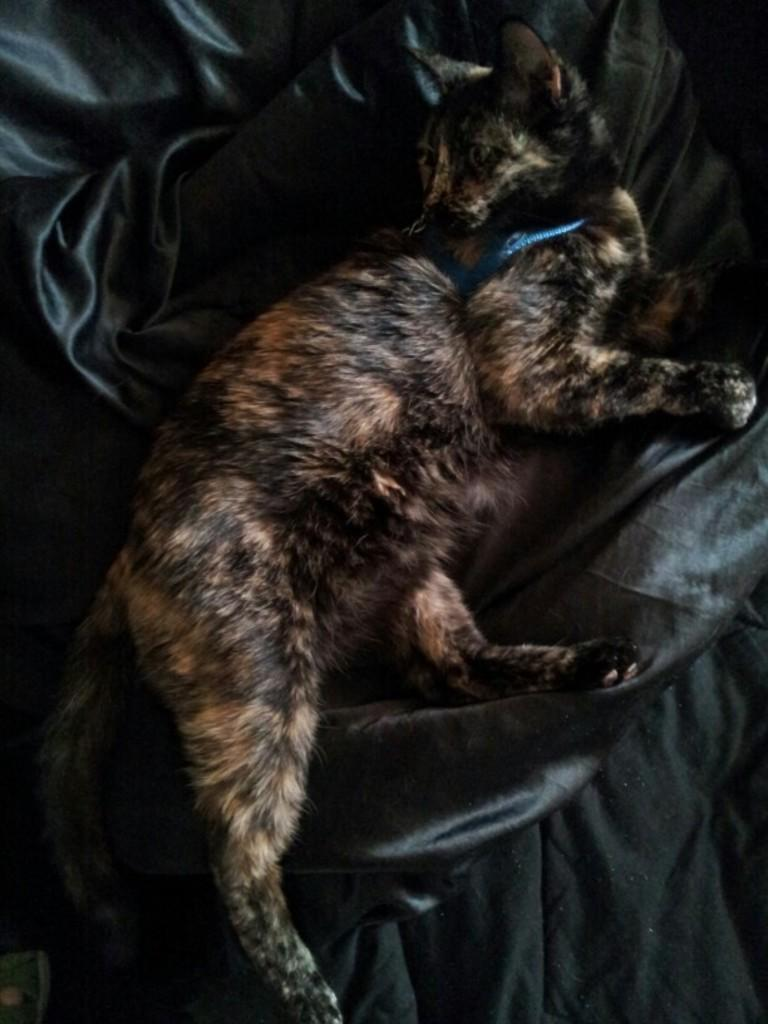What animal is present in the image? There is a cat in the image. What is the cat lying on? The cat is lying on a black color cloth. What is the cat wearing? The cat is wearing some object. What type of voice does the cat have in the image? Cats do not have a voice in the sense of human speech, but they do communicate through meows and other vocalizations. However, since the image is still, we cannot determine the cat's vocalizations from the image alone. 